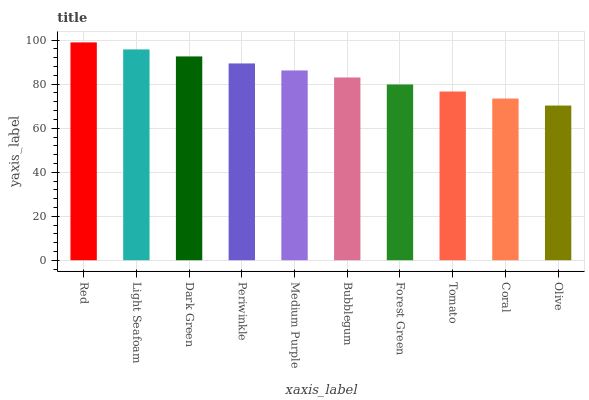Is Olive the minimum?
Answer yes or no. Yes. Is Red the maximum?
Answer yes or no. Yes. Is Light Seafoam the minimum?
Answer yes or no. No. Is Light Seafoam the maximum?
Answer yes or no. No. Is Red greater than Light Seafoam?
Answer yes or no. Yes. Is Light Seafoam less than Red?
Answer yes or no. Yes. Is Light Seafoam greater than Red?
Answer yes or no. No. Is Red less than Light Seafoam?
Answer yes or no. No. Is Medium Purple the high median?
Answer yes or no. Yes. Is Bubblegum the low median?
Answer yes or no. Yes. Is Light Seafoam the high median?
Answer yes or no. No. Is Coral the low median?
Answer yes or no. No. 